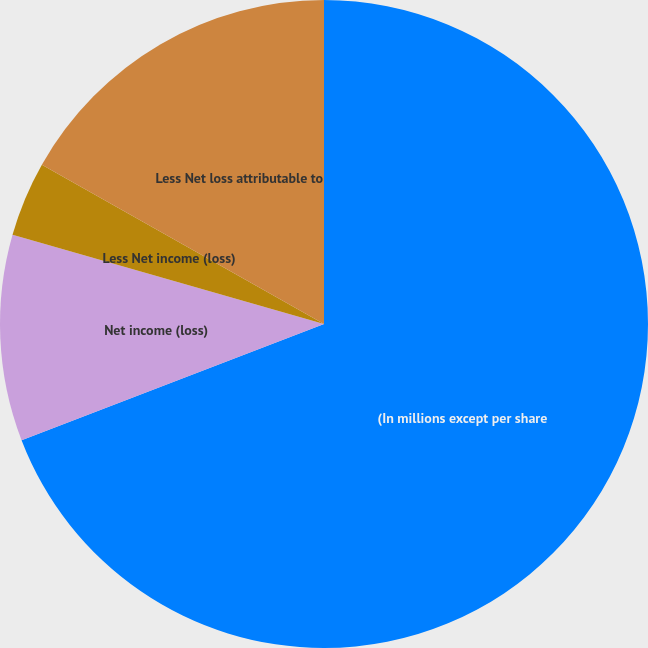Convert chart. <chart><loc_0><loc_0><loc_500><loc_500><pie_chart><fcel>(In millions except per share<fcel>Net income (loss)<fcel>Less Net income (loss)<fcel>Less Net loss attributable to<nl><fcel>69.16%<fcel>10.28%<fcel>3.74%<fcel>16.82%<nl></chart> 